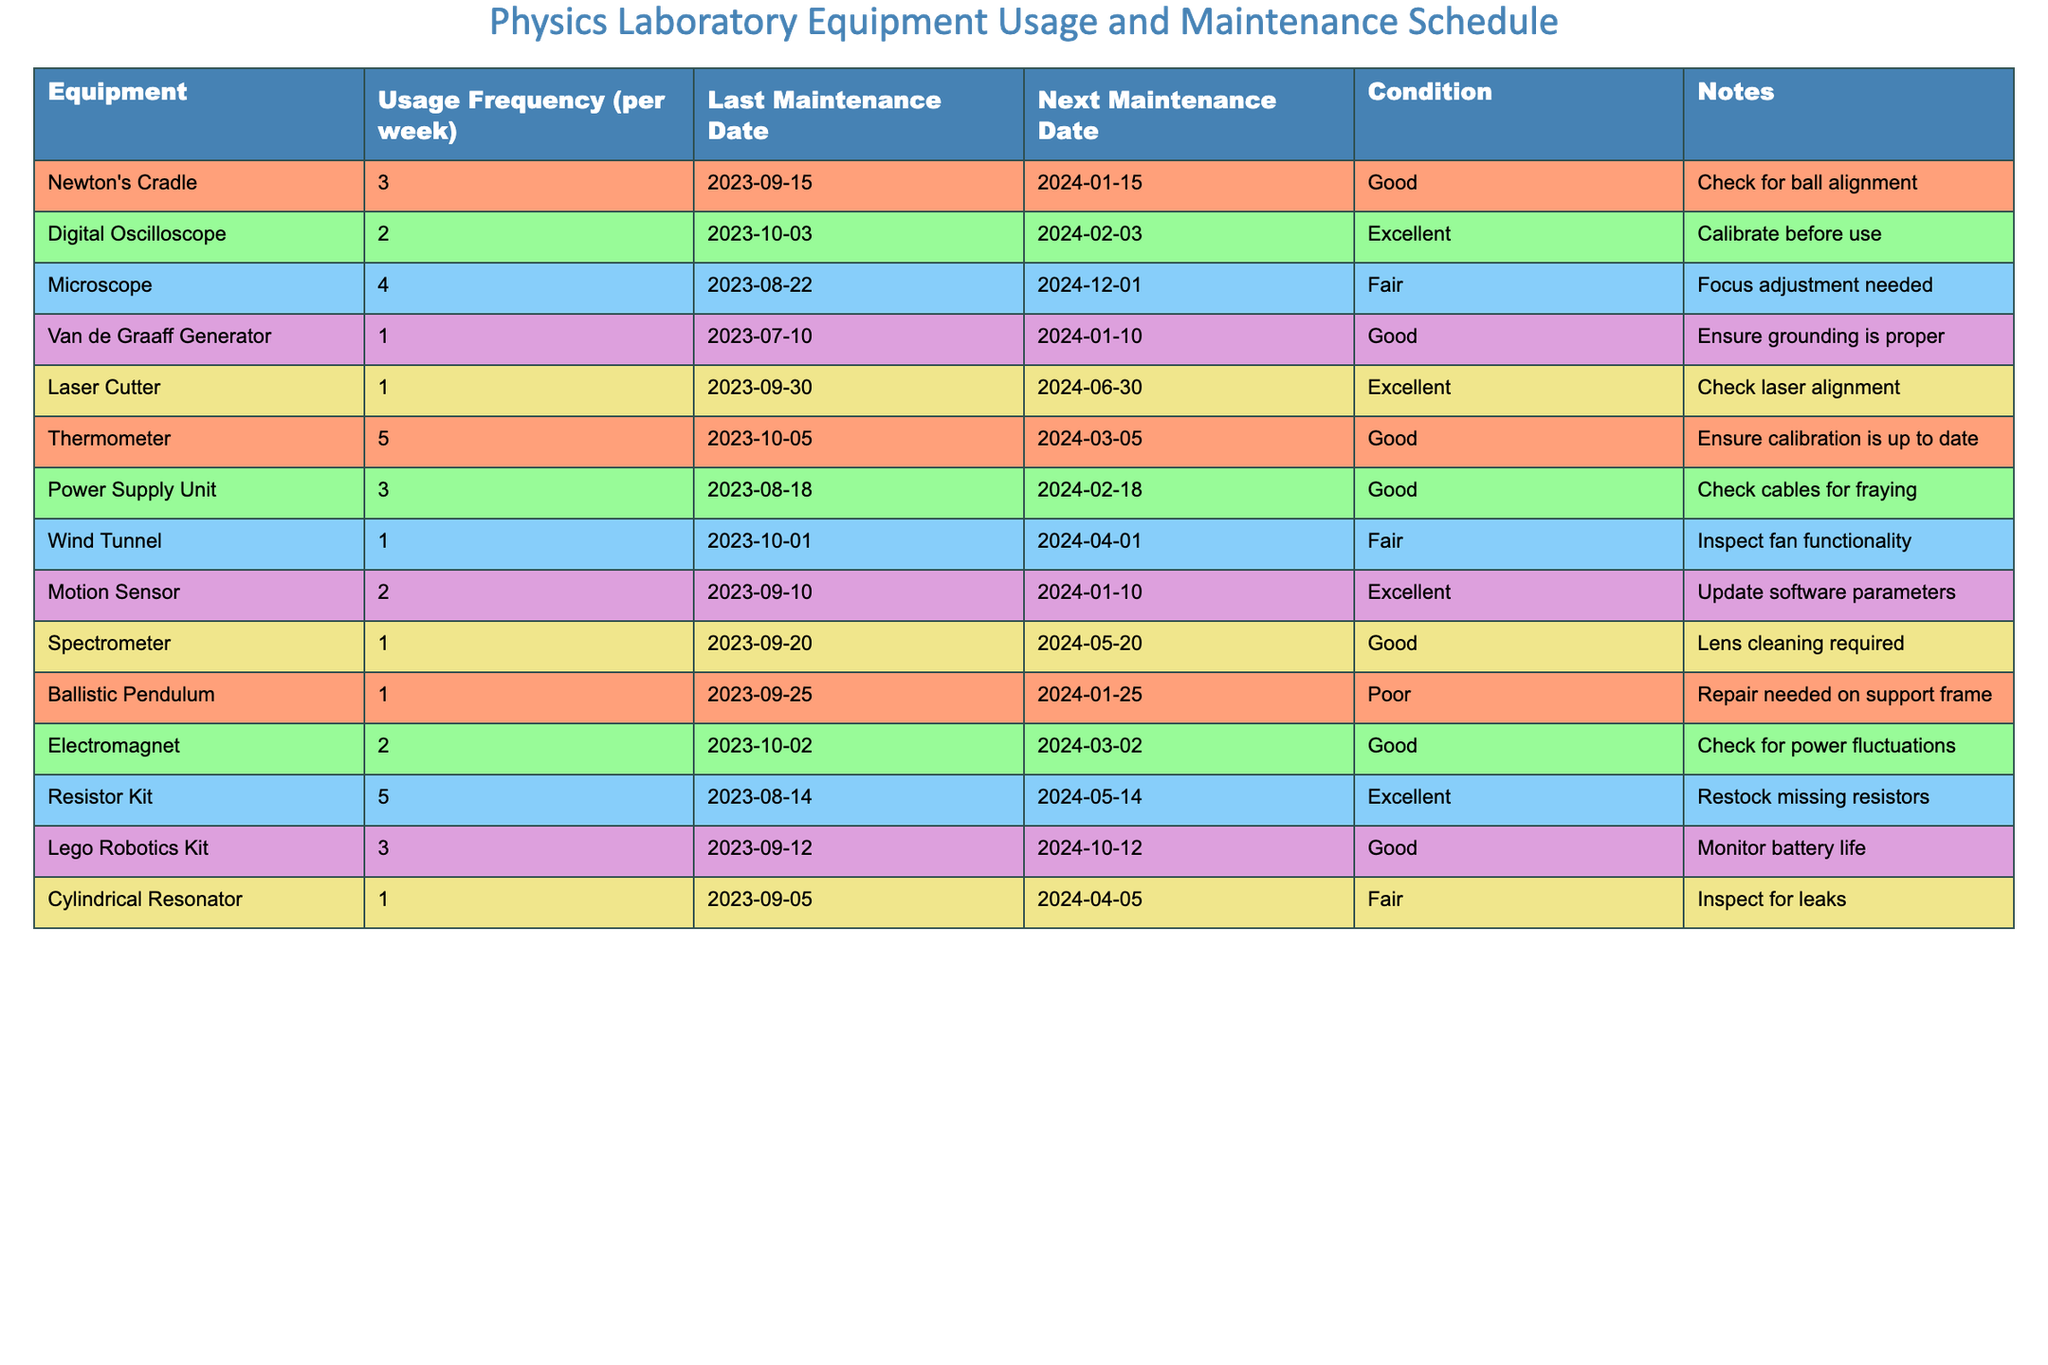What is the usage frequency of the Digital Oscilloscope? The table lists the "Usage Frequency (per week)" for each piece of equipment. For the Digital Oscilloscope, the frequency is noted next to its name.
Answer: 2 Which equipment has the next maintenance date closest to today? By comparing the "Next Maintenance Date" for all the equipment listed, we see the equipment with the earliest date is the Van de Graaff Generator, which is due on 2024-01-10.
Answer: Van de Graaff Generator What is the condition of the Ballistic Pendulum? The table provides the "Condition" of equipment, and for the Ballistic Pendulum, its stated condition is reflected next to it.
Answer: Poor How many pieces of equipment have a usage frequency of 1 per week? We can count the entries in the "Usage Frequency" column that equal 1, which gives us a total of four pieces of equipment.
Answer: 4 Are all the pieces of equipment in good condition? By reviewing the "Condition" column, we can see that not all equipment is classified as "Good"; specifically, the Ballistic Pendulum is poor.
Answer: No Which equipment requires calibration before use, and when was its last maintenance? From the table, the Digital Oscilloscope is the only equipment that requires calibration, and its last maintenance date is 2023-10-03.
Answer: Digital Oscilloscope, 2023-10-03 What is the average usage frequency of all equipment listed? To calculate the average, we sum the usage frequencies: (3 + 2 + 4 + 1 + 1 + 5 + 3 + 1 + 2 + 1 + 2 + 5 + 3 + 1) = 30. There are 14 pieces of equipment, so the average is 30 / 14, which equals approximately 2.14.
Answer: 2.14 Which piece of equipment has no maintenance scheduled until after June 2024? Reviewing the "Next Maintenance Date," the Laser Cutter has its next maintenance on 2024-06-30, indicating it is the only equipment without maintenance needed until that time.
Answer: Laser Cutter How many pieces of equipment require repair based on the condition noted? By examining the "Condition" column, we notice that only the Ballistic Pendulum is marked as requiring repair, totaling one piece of equipment.
Answer: 1 What do we need to check for the Thermometer according to the notes? The table's notes for the Thermometer indicate that we need to ensure its calibration is up to date.
Answer: Ensure calibration is up to date 